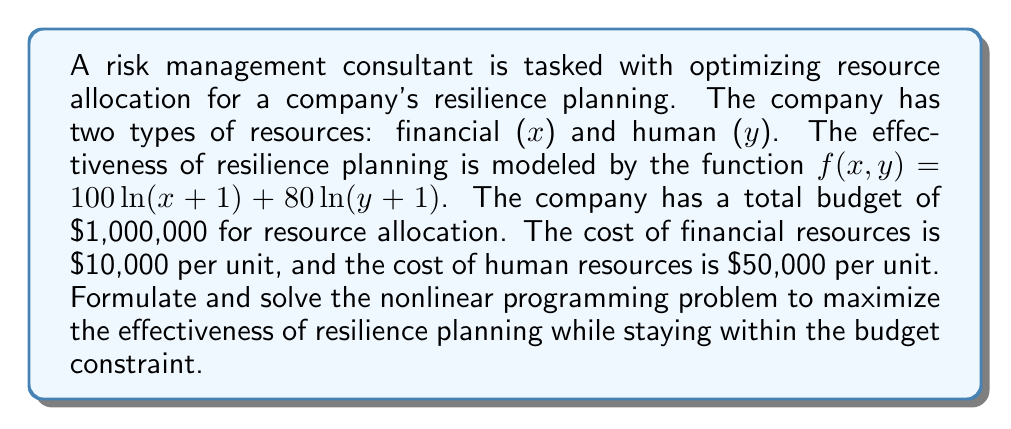Can you solve this math problem? 1. Formulate the objective function:
   Maximize $f(x,y) = 100\ln(x+1) + 80\ln(y+1)$

2. Define the constraint:
   $10000x + 50000y \leq 1000000$

3. Set up the Lagrangian function:
   $L(x,y,\lambda) = 100\ln(x+1) + 80\ln(y+1) - \lambda(10000x + 50000y - 1000000)$

4. Calculate partial derivatives and set them to zero:
   $\frac{\partial L}{\partial x} = \frac{100}{x+1} - 10000\lambda = 0$
   $\frac{\partial L}{\partial y} = \frac{80}{y+1} - 50000\lambda = 0$
   $\frac{\partial L}{\partial \lambda} = 10000x + 50000y - 1000000 = 0$

5. From the first two equations:
   $\frac{100}{x+1} = 10000\lambda$ and $\frac{80}{y+1} = 50000\lambda$

6. Divide these equations:
   $\frac{100}{x+1} \cdot \frac{y+1}{80} = \frac{1}{5}$

7. Solve for y:
   $y = 5x + 4$

8. Substitute into the constraint equation:
   $10000x + 50000(5x + 4) = 1000000$
   $260000x + 200000 = 1000000$
   $260000x = 800000$
   $x = \frac{800000}{260000} = \frac{80}{26} \approx 3.0769$

9. Calculate y:
   $y = 5(\frac{80}{26}) + 4 = \frac{400}{26} + 4 = \frac{504}{26} \approx 19.3846$

10. Round to nearest whole numbers (as we can't allocate partial resources):
    $x = 3$ and $y = 19$
Answer: $x = 3$ financial resource units, $y = 19$ human resource units 